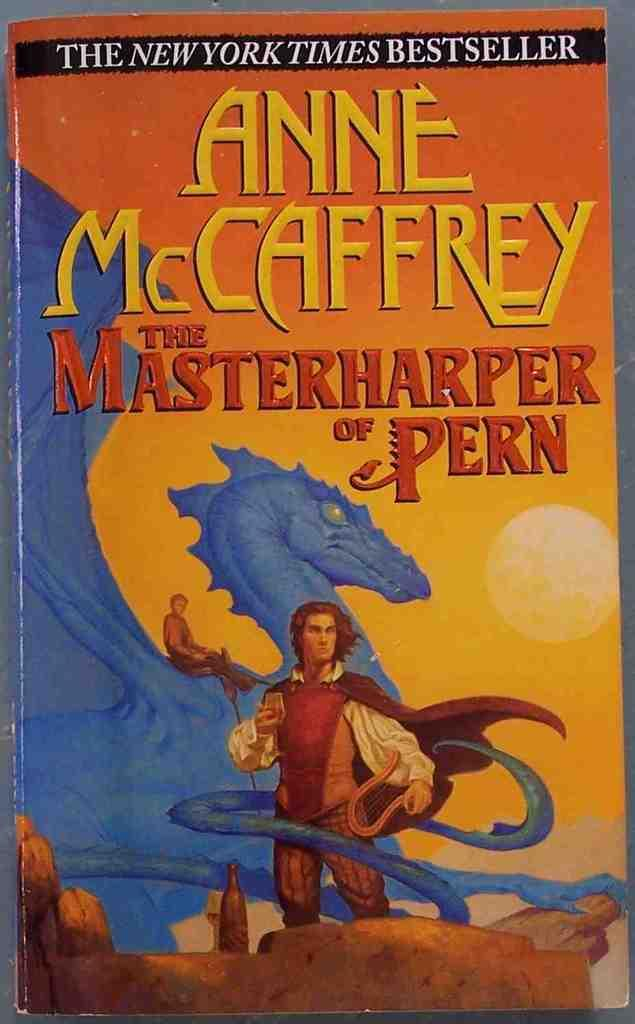<image>
Give a short and clear explanation of the subsequent image. a book which is colofful called the masterharper of pern 